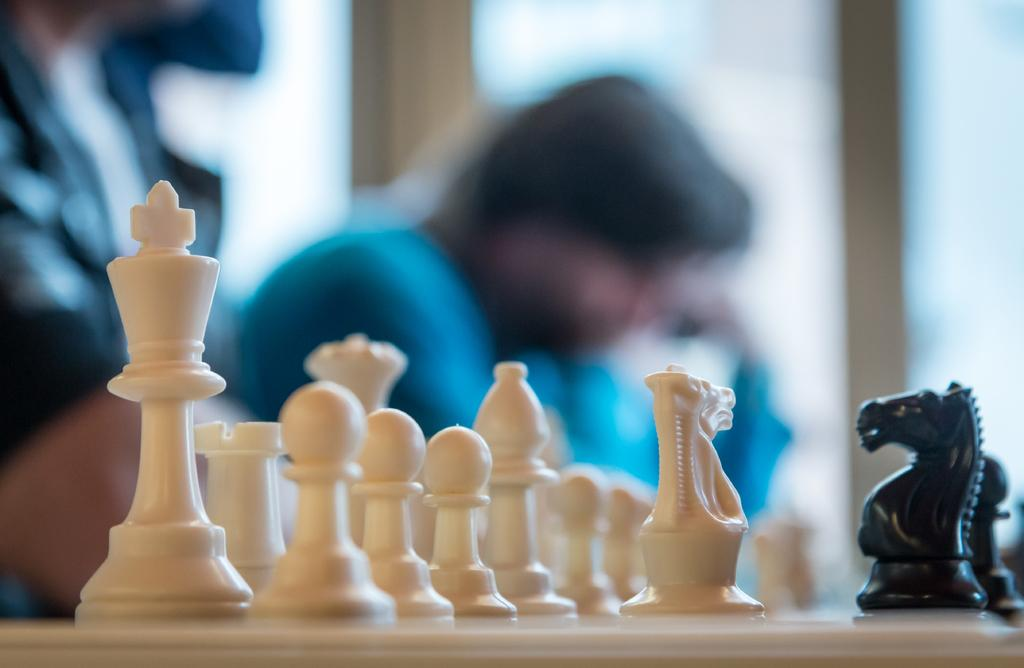What type of game pieces are present in the image? There are chess coins in the image. Can you describe the setting or context of the image? There are persons in the background of the image. What type of beef is being cooked by the persons in the image? There is no beef or cooking activity present in the image; it only features chess coins and persons in the background. 